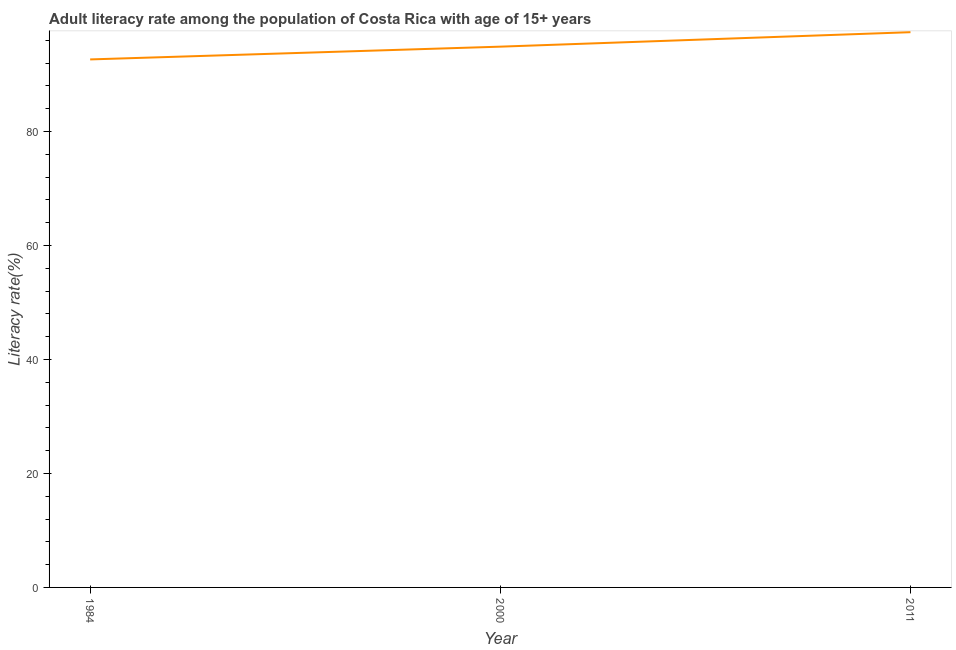What is the adult literacy rate in 1984?
Provide a short and direct response. 92.63. Across all years, what is the maximum adult literacy rate?
Give a very brief answer. 97.41. Across all years, what is the minimum adult literacy rate?
Your answer should be compact. 92.63. What is the sum of the adult literacy rate?
Your answer should be very brief. 284.9. What is the difference between the adult literacy rate in 1984 and 2011?
Your answer should be compact. -4.78. What is the average adult literacy rate per year?
Your response must be concise. 94.97. What is the median adult literacy rate?
Your answer should be very brief. 94.87. Do a majority of the years between 2011 and 1984 (inclusive) have adult literacy rate greater than 84 %?
Give a very brief answer. No. What is the ratio of the adult literacy rate in 1984 to that in 2000?
Provide a short and direct response. 0.98. Is the difference between the adult literacy rate in 1984 and 2000 greater than the difference between any two years?
Keep it short and to the point. No. What is the difference between the highest and the second highest adult literacy rate?
Your response must be concise. 2.54. What is the difference between the highest and the lowest adult literacy rate?
Your answer should be very brief. 4.78. In how many years, is the adult literacy rate greater than the average adult literacy rate taken over all years?
Your answer should be very brief. 1. Does the adult literacy rate monotonically increase over the years?
Provide a short and direct response. Yes. How many lines are there?
Keep it short and to the point. 1. What is the title of the graph?
Ensure brevity in your answer.  Adult literacy rate among the population of Costa Rica with age of 15+ years. What is the label or title of the Y-axis?
Offer a very short reply. Literacy rate(%). What is the Literacy rate(%) in 1984?
Give a very brief answer. 92.63. What is the Literacy rate(%) of 2000?
Provide a short and direct response. 94.87. What is the Literacy rate(%) in 2011?
Your response must be concise. 97.41. What is the difference between the Literacy rate(%) in 1984 and 2000?
Offer a terse response. -2.24. What is the difference between the Literacy rate(%) in 1984 and 2011?
Provide a short and direct response. -4.78. What is the difference between the Literacy rate(%) in 2000 and 2011?
Give a very brief answer. -2.54. What is the ratio of the Literacy rate(%) in 1984 to that in 2011?
Your answer should be very brief. 0.95. 